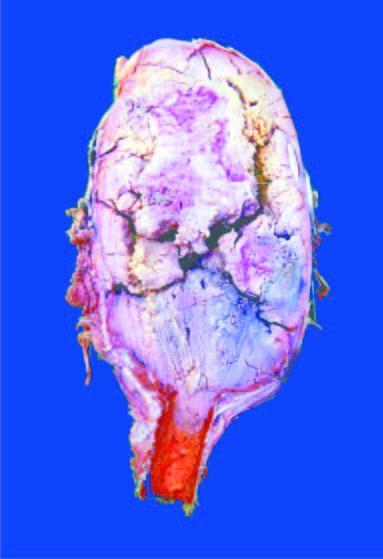s the end of the long bone expanded in the region of epiphysis?
Answer the question using a single word or phrase. Yes 